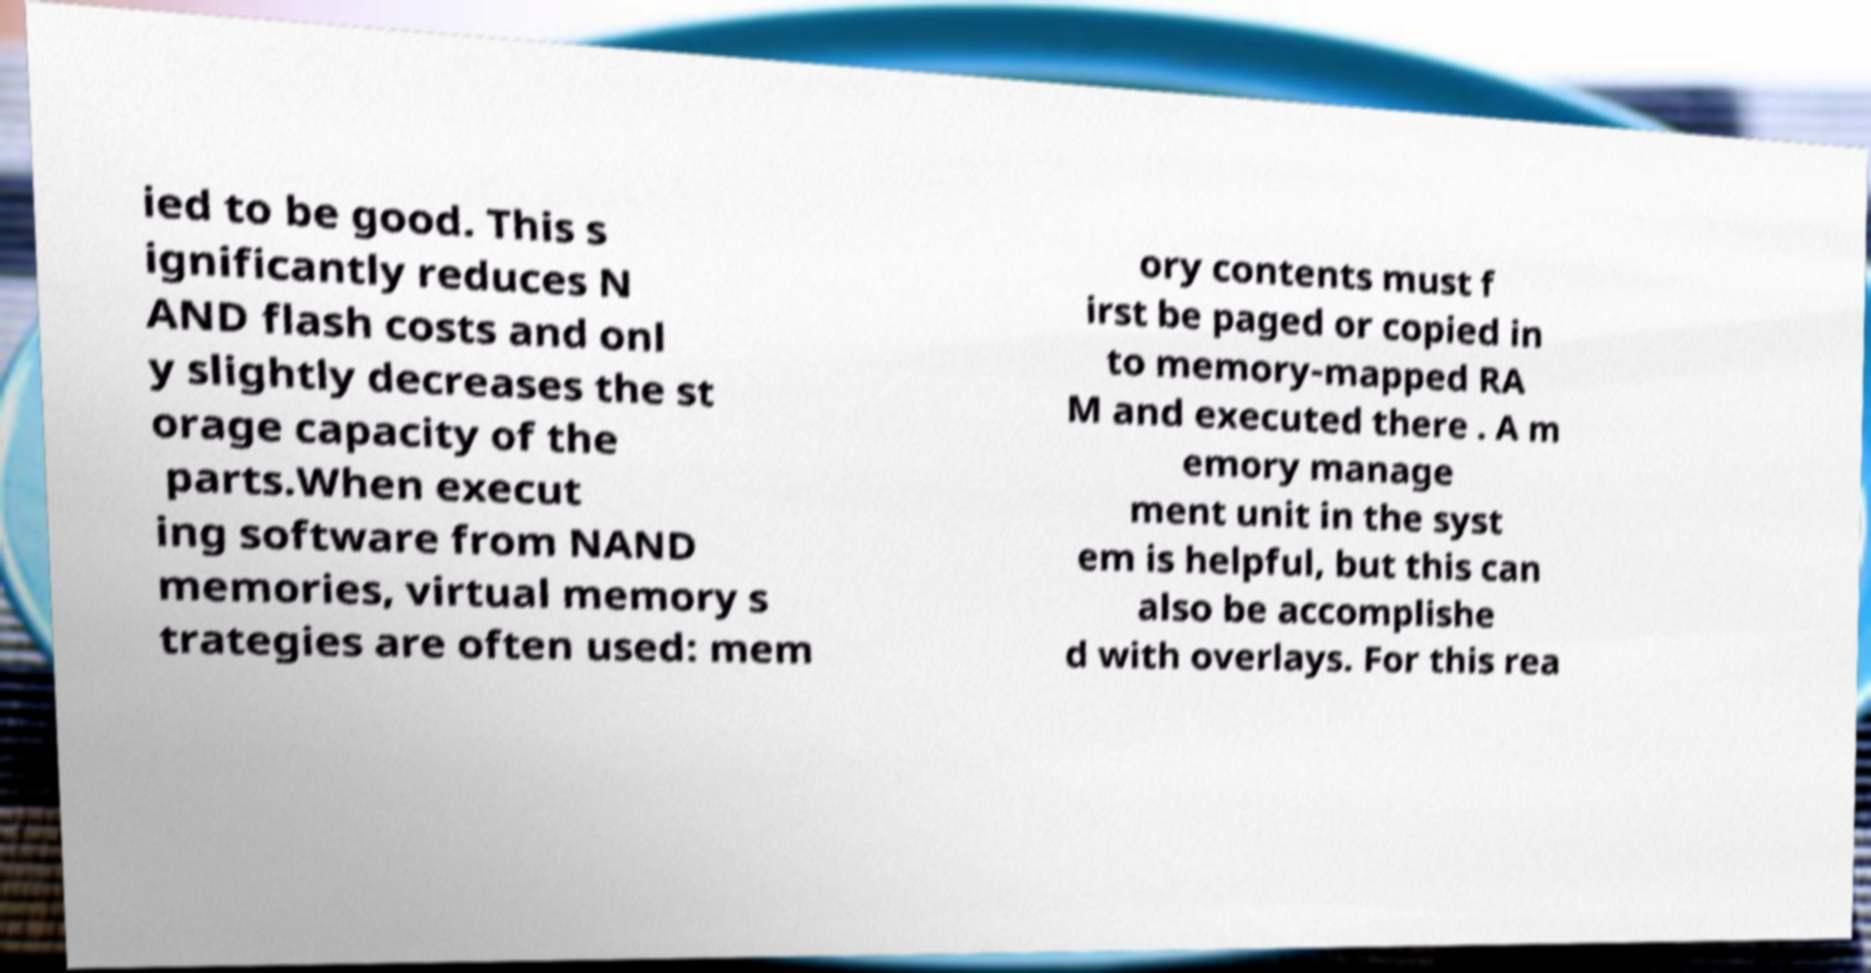What messages or text are displayed in this image? I need them in a readable, typed format. ied to be good. This s ignificantly reduces N AND flash costs and onl y slightly decreases the st orage capacity of the parts.When execut ing software from NAND memories, virtual memory s trategies are often used: mem ory contents must f irst be paged or copied in to memory-mapped RA M and executed there . A m emory manage ment unit in the syst em is helpful, but this can also be accomplishe d with overlays. For this rea 